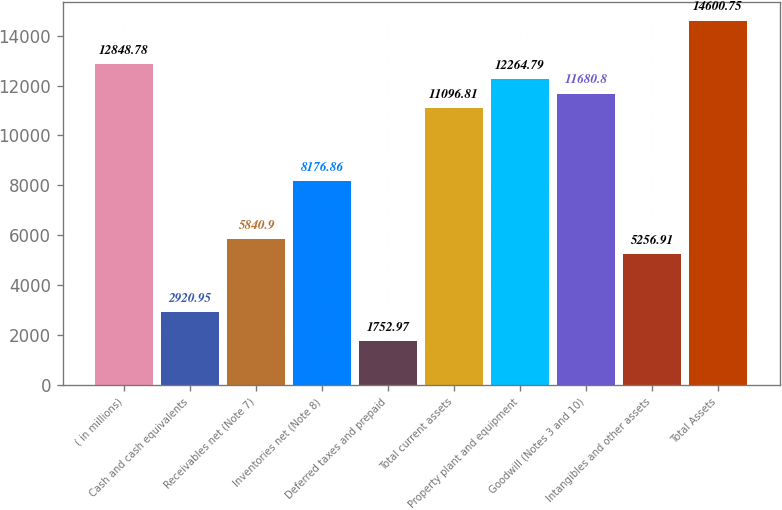Convert chart. <chart><loc_0><loc_0><loc_500><loc_500><bar_chart><fcel>( in millions)<fcel>Cash and cash equivalents<fcel>Receivables net (Note 7)<fcel>Inventories net (Note 8)<fcel>Deferred taxes and prepaid<fcel>Total current assets<fcel>Property plant and equipment<fcel>Goodwill (Notes 3 and 10)<fcel>Intangibles and other assets<fcel>Total Assets<nl><fcel>12848.8<fcel>2920.95<fcel>5840.9<fcel>8176.86<fcel>1752.97<fcel>11096.8<fcel>12264.8<fcel>11680.8<fcel>5256.91<fcel>14600.8<nl></chart> 